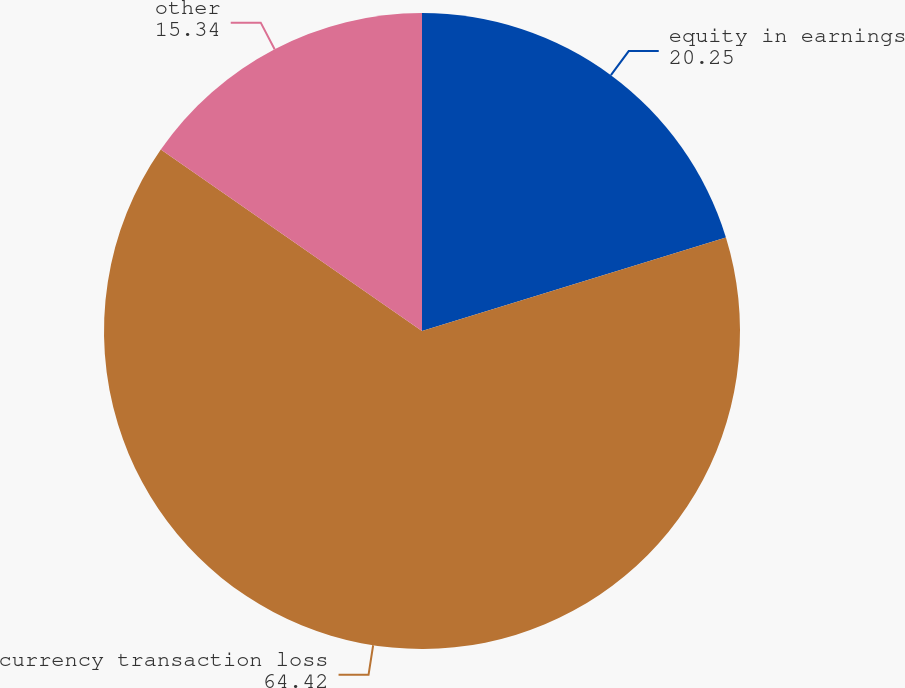Convert chart to OTSL. <chart><loc_0><loc_0><loc_500><loc_500><pie_chart><fcel>equity in earnings<fcel>currency transaction loss<fcel>other<nl><fcel>20.25%<fcel>64.42%<fcel>15.34%<nl></chart> 